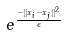Convert formula to latex. <formula><loc_0><loc_0><loc_500><loc_500>e ^ { \frac { - | | x _ { i } - x _ { j } | | ^ { 2 } } { \epsilon } }</formula> 